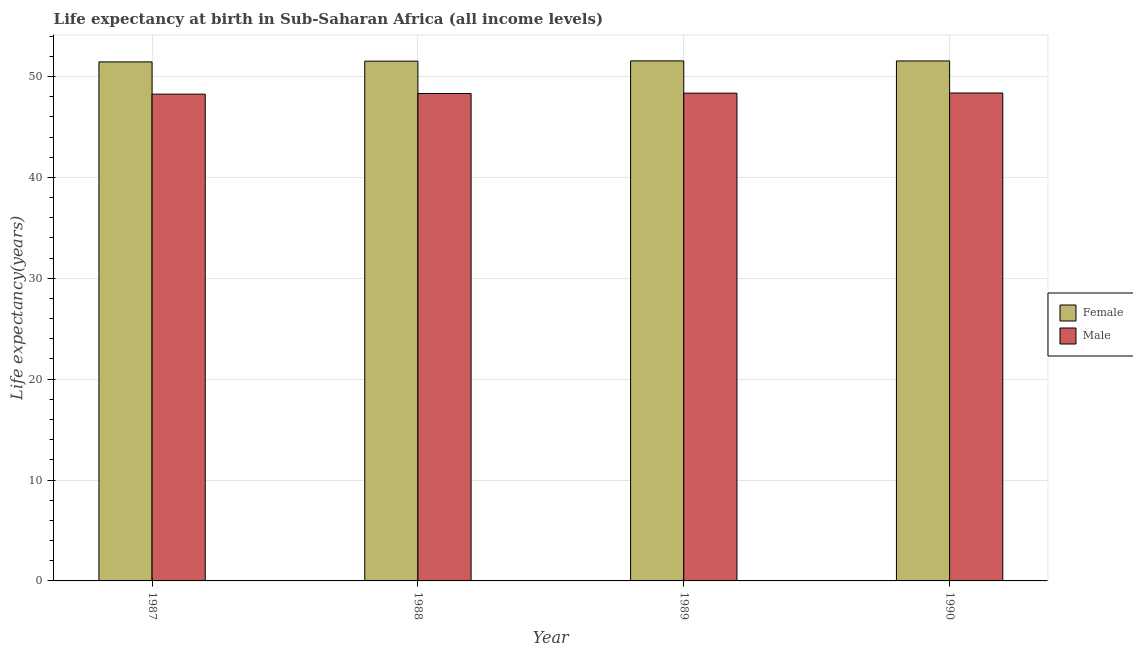How many different coloured bars are there?
Ensure brevity in your answer.  2. Are the number of bars per tick equal to the number of legend labels?
Give a very brief answer. Yes. Are the number of bars on each tick of the X-axis equal?
Your response must be concise. Yes. How many bars are there on the 2nd tick from the left?
Make the answer very short. 2. What is the label of the 4th group of bars from the left?
Give a very brief answer. 1990. In how many cases, is the number of bars for a given year not equal to the number of legend labels?
Your answer should be compact. 0. What is the life expectancy(male) in 1987?
Provide a succinct answer. 48.25. Across all years, what is the maximum life expectancy(male)?
Keep it short and to the point. 48.37. Across all years, what is the minimum life expectancy(male)?
Give a very brief answer. 48.25. What is the total life expectancy(female) in the graph?
Offer a terse response. 206.07. What is the difference between the life expectancy(male) in 1989 and that in 1990?
Offer a terse response. -0.02. What is the difference between the life expectancy(female) in 1990 and the life expectancy(male) in 1988?
Give a very brief answer. 0.02. What is the average life expectancy(male) per year?
Your answer should be very brief. 48.32. What is the ratio of the life expectancy(female) in 1988 to that in 1989?
Provide a succinct answer. 1. What is the difference between the highest and the second highest life expectancy(female)?
Your response must be concise. 0.01. What is the difference between the highest and the lowest life expectancy(female)?
Ensure brevity in your answer.  0.1. In how many years, is the life expectancy(female) greater than the average life expectancy(female) taken over all years?
Offer a very short reply. 3. What does the 2nd bar from the right in 1990 represents?
Make the answer very short. Female. How many bars are there?
Your response must be concise. 8. Are all the bars in the graph horizontal?
Provide a short and direct response. No. What is the difference between two consecutive major ticks on the Y-axis?
Your answer should be very brief. 10. Are the values on the major ticks of Y-axis written in scientific E-notation?
Offer a terse response. No. Does the graph contain grids?
Provide a succinct answer. Yes. Where does the legend appear in the graph?
Give a very brief answer. Center right. How many legend labels are there?
Offer a terse response. 2. What is the title of the graph?
Your answer should be compact. Life expectancy at birth in Sub-Saharan Africa (all income levels). Does "Broad money growth" appear as one of the legend labels in the graph?
Provide a short and direct response. No. What is the label or title of the Y-axis?
Give a very brief answer. Life expectancy(years). What is the Life expectancy(years) of Female in 1987?
Provide a short and direct response. 51.45. What is the Life expectancy(years) of Male in 1987?
Ensure brevity in your answer.  48.25. What is the Life expectancy(years) in Female in 1988?
Offer a terse response. 51.52. What is the Life expectancy(years) of Male in 1988?
Offer a terse response. 48.32. What is the Life expectancy(years) in Female in 1989?
Provide a succinct answer. 51.55. What is the Life expectancy(years) of Male in 1989?
Your answer should be very brief. 48.35. What is the Life expectancy(years) of Female in 1990?
Make the answer very short. 51.54. What is the Life expectancy(years) in Male in 1990?
Your response must be concise. 48.37. Across all years, what is the maximum Life expectancy(years) in Female?
Your response must be concise. 51.55. Across all years, what is the maximum Life expectancy(years) of Male?
Your answer should be compact. 48.37. Across all years, what is the minimum Life expectancy(years) in Female?
Offer a very short reply. 51.45. Across all years, what is the minimum Life expectancy(years) in Male?
Provide a short and direct response. 48.25. What is the total Life expectancy(years) in Female in the graph?
Your answer should be compact. 206.07. What is the total Life expectancy(years) of Male in the graph?
Provide a succinct answer. 193.28. What is the difference between the Life expectancy(years) in Female in 1987 and that in 1988?
Give a very brief answer. -0.07. What is the difference between the Life expectancy(years) of Male in 1987 and that in 1988?
Keep it short and to the point. -0.07. What is the difference between the Life expectancy(years) in Female in 1987 and that in 1989?
Offer a terse response. -0.1. What is the difference between the Life expectancy(years) of Male in 1987 and that in 1989?
Ensure brevity in your answer.  -0.1. What is the difference between the Life expectancy(years) in Female in 1987 and that in 1990?
Your response must be concise. -0.09. What is the difference between the Life expectancy(years) of Male in 1987 and that in 1990?
Provide a short and direct response. -0.12. What is the difference between the Life expectancy(years) of Female in 1988 and that in 1989?
Your answer should be compact. -0.03. What is the difference between the Life expectancy(years) of Male in 1988 and that in 1989?
Your answer should be compact. -0.03. What is the difference between the Life expectancy(years) in Female in 1988 and that in 1990?
Keep it short and to the point. -0.02. What is the difference between the Life expectancy(years) in Male in 1988 and that in 1990?
Your answer should be compact. -0.05. What is the difference between the Life expectancy(years) of Female in 1989 and that in 1990?
Your response must be concise. 0.01. What is the difference between the Life expectancy(years) of Male in 1989 and that in 1990?
Offer a very short reply. -0.01. What is the difference between the Life expectancy(years) of Female in 1987 and the Life expectancy(years) of Male in 1988?
Make the answer very short. 3.13. What is the difference between the Life expectancy(years) of Female in 1987 and the Life expectancy(years) of Male in 1989?
Ensure brevity in your answer.  3.1. What is the difference between the Life expectancy(years) in Female in 1987 and the Life expectancy(years) in Male in 1990?
Your response must be concise. 3.08. What is the difference between the Life expectancy(years) of Female in 1988 and the Life expectancy(years) of Male in 1989?
Ensure brevity in your answer.  3.17. What is the difference between the Life expectancy(years) of Female in 1988 and the Life expectancy(years) of Male in 1990?
Keep it short and to the point. 3.16. What is the difference between the Life expectancy(years) of Female in 1989 and the Life expectancy(years) of Male in 1990?
Ensure brevity in your answer.  3.18. What is the average Life expectancy(years) of Female per year?
Provide a succinct answer. 51.52. What is the average Life expectancy(years) of Male per year?
Keep it short and to the point. 48.32. In the year 1987, what is the difference between the Life expectancy(years) of Female and Life expectancy(years) of Male?
Provide a short and direct response. 3.2. In the year 1988, what is the difference between the Life expectancy(years) in Female and Life expectancy(years) in Male?
Make the answer very short. 3.21. In the year 1989, what is the difference between the Life expectancy(years) in Female and Life expectancy(years) in Male?
Make the answer very short. 3.2. In the year 1990, what is the difference between the Life expectancy(years) in Female and Life expectancy(years) in Male?
Provide a succinct answer. 3.18. What is the ratio of the Life expectancy(years) in Male in 1987 to that in 1989?
Keep it short and to the point. 1. What is the ratio of the Life expectancy(years) of Female in 1988 to that in 1989?
Ensure brevity in your answer.  1. What is the ratio of the Life expectancy(years) of Male in 1988 to that in 1989?
Your answer should be compact. 1. What is the ratio of the Life expectancy(years) of Male in 1989 to that in 1990?
Your response must be concise. 1. What is the difference between the highest and the second highest Life expectancy(years) of Female?
Ensure brevity in your answer.  0.01. What is the difference between the highest and the second highest Life expectancy(years) in Male?
Provide a short and direct response. 0.01. What is the difference between the highest and the lowest Life expectancy(years) of Female?
Your answer should be very brief. 0.1. What is the difference between the highest and the lowest Life expectancy(years) of Male?
Ensure brevity in your answer.  0.12. 